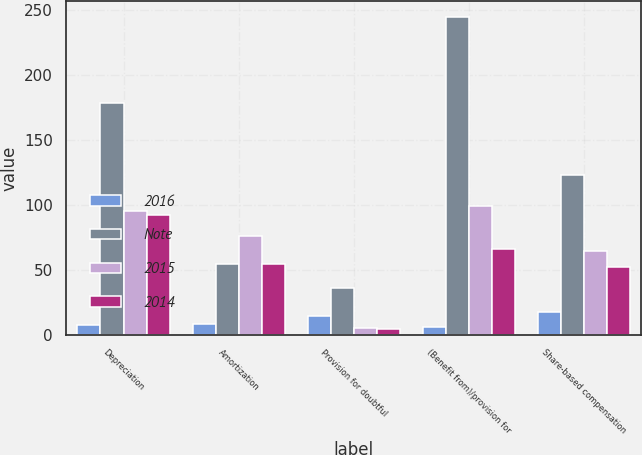Convert chart to OTSL. <chart><loc_0><loc_0><loc_500><loc_500><stacked_bar_chart><ecel><fcel>Depreciation<fcel>Amortization<fcel>Provision for doubtful<fcel>(Benefit from)/provision for<fcel>Share-based compensation<nl><fcel>2016<fcel>7<fcel>8<fcel>14<fcel>6<fcel>17<nl><fcel>Note<fcel>178<fcel>54<fcel>36<fcel>244<fcel>123<nl><fcel>2015<fcel>95<fcel>76<fcel>5<fcel>99<fcel>64<nl><fcel>2014<fcel>92<fcel>54<fcel>4<fcel>66<fcel>52<nl></chart> 